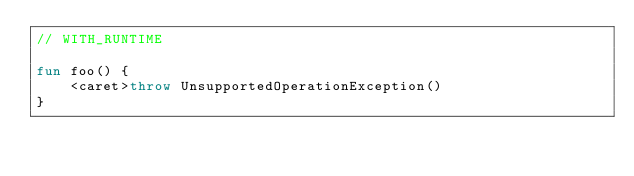Convert code to text. <code><loc_0><loc_0><loc_500><loc_500><_Kotlin_>// WITH_RUNTIME

fun foo() {
    <caret>throw UnsupportedOperationException()
}
</code> 